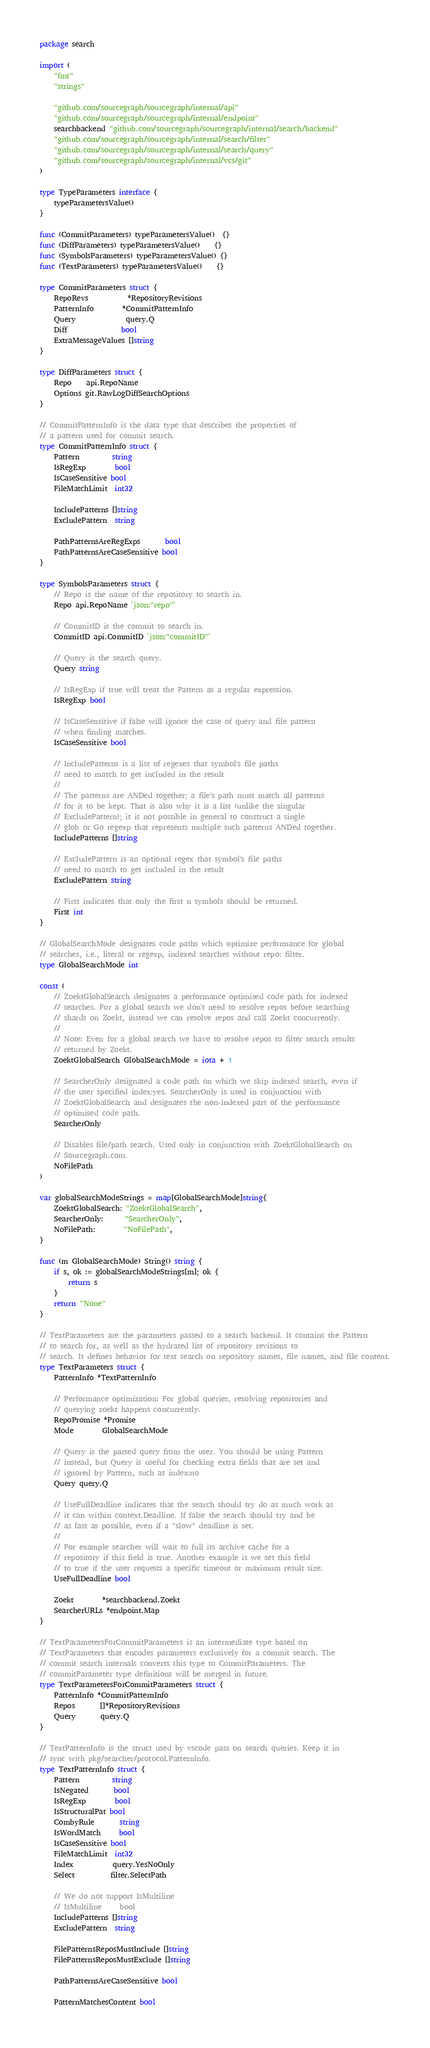<code> <loc_0><loc_0><loc_500><loc_500><_Go_>package search

import (
	"fmt"
	"strings"

	"github.com/sourcegraph/sourcegraph/internal/api"
	"github.com/sourcegraph/sourcegraph/internal/endpoint"
	searchbackend "github.com/sourcegraph/sourcegraph/internal/search/backend"
	"github.com/sourcegraph/sourcegraph/internal/search/filter"
	"github.com/sourcegraph/sourcegraph/internal/search/query"
	"github.com/sourcegraph/sourcegraph/internal/vcs/git"
)

type TypeParameters interface {
	typeParametersValue()
}

func (CommitParameters) typeParametersValue()  {}
func (DiffParameters) typeParametersValue()    {}
func (SymbolsParameters) typeParametersValue() {}
func (TextParameters) typeParametersValue()    {}

type CommitParameters struct {
	RepoRevs           *RepositoryRevisions
	PatternInfo        *CommitPatternInfo
	Query              query.Q
	Diff               bool
	ExtraMessageValues []string
}

type DiffParameters struct {
	Repo    api.RepoName
	Options git.RawLogDiffSearchOptions
}

// CommitPatternInfo is the data type that describes the properties of
// a pattern used for commit search.
type CommitPatternInfo struct {
	Pattern         string
	IsRegExp        bool
	IsCaseSensitive bool
	FileMatchLimit  int32

	IncludePatterns []string
	ExcludePattern  string

	PathPatternsAreRegExps       bool
	PathPatternsAreCaseSensitive bool
}

type SymbolsParameters struct {
	// Repo is the name of the repository to search in.
	Repo api.RepoName `json:"repo"`

	// CommitID is the commit to search in.
	CommitID api.CommitID `json:"commitID"`

	// Query is the search query.
	Query string

	// IsRegExp if true will treat the Pattern as a regular expression.
	IsRegExp bool

	// IsCaseSensitive if false will ignore the case of query and file pattern
	// when finding matches.
	IsCaseSensitive bool

	// IncludePatterns is a list of regexes that symbol's file paths
	// need to match to get included in the result
	//
	// The patterns are ANDed together; a file's path must match all patterns
	// for it to be kept. That is also why it is a list (unlike the singular
	// ExcludePattern); it is not possible in general to construct a single
	// glob or Go regexp that represents multiple such patterns ANDed together.
	IncludePatterns []string

	// ExcludePattern is an optional regex that symbol's file paths
	// need to match to get included in the result
	ExcludePattern string

	// First indicates that only the first n symbols should be returned.
	First int
}

// GlobalSearchMode designates code paths which optimize performance for global
// searches, i.e., literal or regexp, indexed searches without repo: filter.
type GlobalSearchMode int

const (
	// ZoektGlobalSearch designates a performance optimised code path for indexed
	// searches. For a global search we don't need to resolve repos before searching
	// shards on Zoekt, instead we can resolve repos and call Zoekt concurrently.
	//
	// Note: Even for a global search we have to resolve repos to filter search results
	// returned by Zoekt.
	ZoektGlobalSearch GlobalSearchMode = iota + 1

	// SearcherOnly designated a code path on which we skip indexed search, even if
	// the user specified index:yes. SearcherOnly is used in conjunction with
	// ZoektGlobalSearch and designates the non-indexed part of the performance
	// optimised code path.
	SearcherOnly

	// Disables file/path search. Used only in conjunction with ZoektGlobalSearch on
	// Sourcegraph.com.
	NoFilePath
)

var globalSearchModeStrings = map[GlobalSearchMode]string{
	ZoektGlobalSearch: "ZoektGlobalSearch",
	SearcherOnly:      "SearcherOnly",
	NoFilePath:        "NoFilePath",
}

func (m GlobalSearchMode) String() string {
	if s, ok := globalSearchModeStrings[m]; ok {
		return s
	}
	return "None"
}

// TextParameters are the parameters passed to a search backend. It contains the Pattern
// to search for, as well as the hydrated list of repository revisions to
// search. It defines behavior for text search on repository names, file names, and file content.
type TextParameters struct {
	PatternInfo *TextPatternInfo

	// Performance optimization: For global queries, resolving repositories and
	// querying zoekt happens concurrently.
	RepoPromise *Promise
	Mode        GlobalSearchMode

	// Query is the parsed query from the user. You should be using Pattern
	// instead, but Query is useful for checking extra fields that are set and
	// ignored by Pattern, such as index:no
	Query query.Q

	// UseFullDeadline indicates that the search should try do as much work as
	// it can within context.Deadline. If false the search should try and be
	// as fast as possible, even if a "slow" deadline is set.
	//
	// For example searcher will wait to full its archive cache for a
	// repository if this field is true. Another example is we set this field
	// to true if the user requests a specific timeout or maximum result size.
	UseFullDeadline bool

	Zoekt        *searchbackend.Zoekt
	SearcherURLs *endpoint.Map
}

// TextParametersForCommitParameters is an intermediate type based on
// TextParameters that encodes parameters exclusively for a commit search. The
// commit search internals converts this type to CommitParameters. The
// commitParameter type definitions will be merged in future.
type TextParametersForCommitParameters struct {
	PatternInfo *CommitPatternInfo
	Repos       []*RepositoryRevisions
	Query       query.Q
}

// TextPatternInfo is the struct used by vscode pass on search queries. Keep it in
// sync with pkg/searcher/protocol.PatternInfo.
type TextPatternInfo struct {
	Pattern         string
	IsNegated       bool
	IsRegExp        bool
	IsStructuralPat bool
	CombyRule       string
	IsWordMatch     bool
	IsCaseSensitive bool
	FileMatchLimit  int32
	Index           query.YesNoOnly
	Select          filter.SelectPath

	// We do not support IsMultiline
	// IsMultiline     bool
	IncludePatterns []string
	ExcludePattern  string

	FilePatternsReposMustInclude []string
	FilePatternsReposMustExclude []string

	PathPatternsAreCaseSensitive bool

	PatternMatchesContent bool</code> 